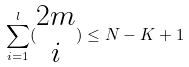Convert formula to latex. <formula><loc_0><loc_0><loc_500><loc_500>\sum _ { i = 1 } ^ { l } ( \begin{matrix} 2 m \\ i \end{matrix} ) \leq N - K + 1</formula> 